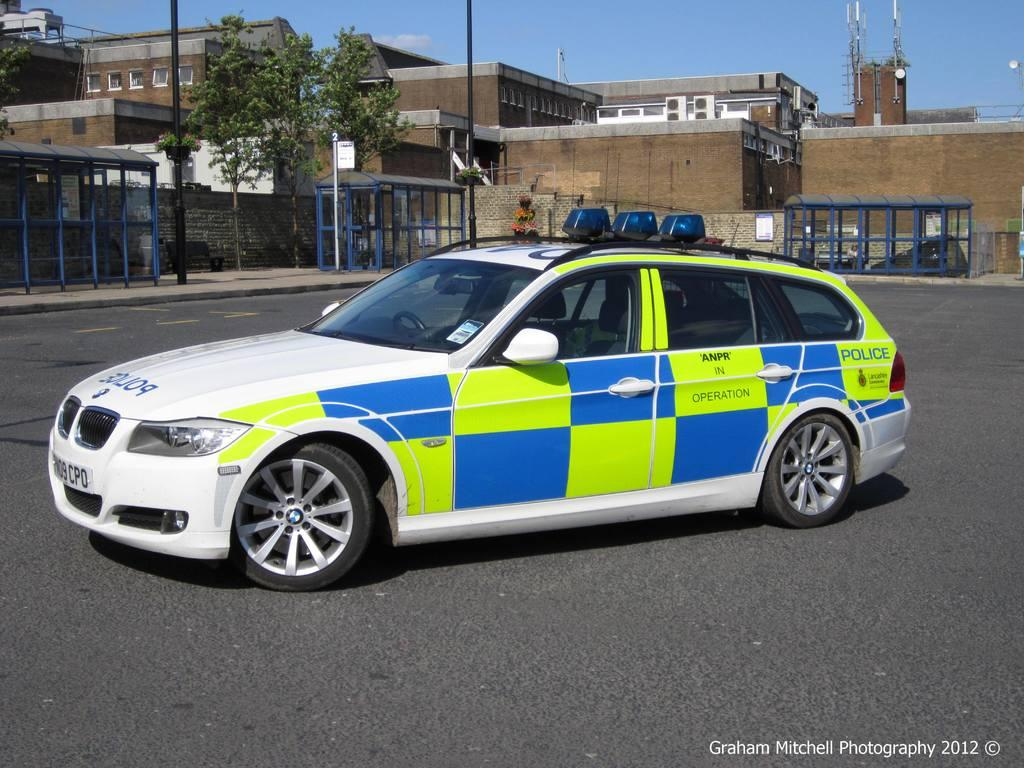What is the main subject of the image? The main subject of the image is a car. Where is the car located in the image? The car is on the road in the image. Can you describe the colors of the car? The car has blue, green, and white colors. What can be seen in the background of the image? There are buildings, trees, and the sky visible in the background of the image. What type of wine is being served at the car's hourly event in the image? There is no wine or event present in the image; it features a car on the road with a background of buildings, trees, and the sky. 